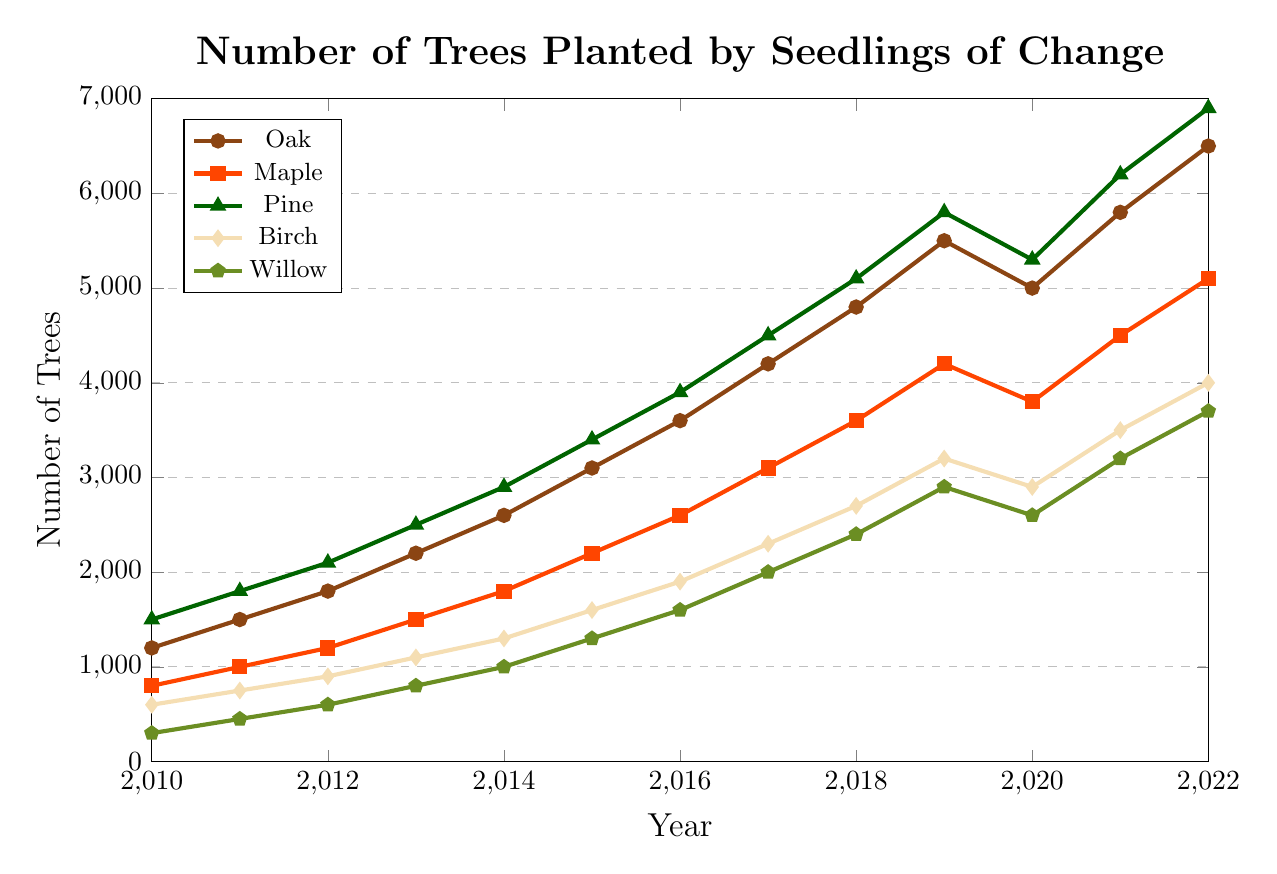How many more Oak trees were planted in 2022 compared to 2010? In 2010, 1200 Oak trees were planted, and in 2022, 6500 Oak trees were planted. To find the difference, subtract 1200 from 6500: \(6500 - 1200 = 5300\).
Answer: 5300 Which year had the highest number of Maple trees planted? Observing the Maple line in the chart, the number planted in 2022 is the highest at 5100.
Answer: 2022 What is the average number of Pine trees planted per year from 2010 to 2022? Add up the yearly plantings, then divide by the number of years: \((1500 + 1800 + 2100 + 2500 + 2900 + 3400 + 3900 + 4500 + 5100 + 5800 + 5300 + 6200 + 6900) / 13\). The sum is 53900, so the average is \(53900 / 13 = 4146.15\).
Answer: 4146.15 Between Birch and Willow trees, which species saw a higher increase in number planted from 2010 to 2022? For Birch, the increase is \(4000 - 600 = 3400\); for Willow, the increase is \(3700 - 300 = 3400\). Both species saw an increase of 3400.
Answer: Both What was the cumulative number of all species planted in 2015? Add up the numbers for each species: \(3100 + 2200 + 3400 + 1600 + 1300\). The sum is 11600.
Answer: 11600 Was there any year where the number of Birch trees planted decreased from the previous year? Observing the Birch line, the planted numbers of Birch trees slightly dropped in 2020 compared to 2019: 2900 in 2020 and 3200 in 2019.
Answer: 2020 Did any species see a reduction in the number of trees planted in 2020 compared to 2019? The Oak, Maple, Pine, and Birch trees all experienced a drop in 2020 compared to 2019. The plotted points verify this drop for these trees. Willow trees also experienced a drop. - For example, Oak's decrease: 5500 in 2019 to 5000 in 2020
Answer: Yes Which species had the most consistent year-over-year increase in the number of trees planted from 2010 to 2022? By examining the chart, the Oak line appears consistently increasing with a minor drop only in 2020.
Answer: Oak How many Pine trees were planted in 2014 and 2015 combined? Add the numbers for Pine in 2014 and 2015: \(2900 + 3400 = 6300\).
Answer: 6300 What is the total number of Willow trees planted from 2010 to 2022? Sum up Willow trees for all years from 2010 to 2022: \(300 + 450 + 600 + 800 + 1000 + 1300 + 1600 + 2000 + 2400 + 2900 + 2600 + 3200 + 3700 = 22850\).
Answer: 22850 